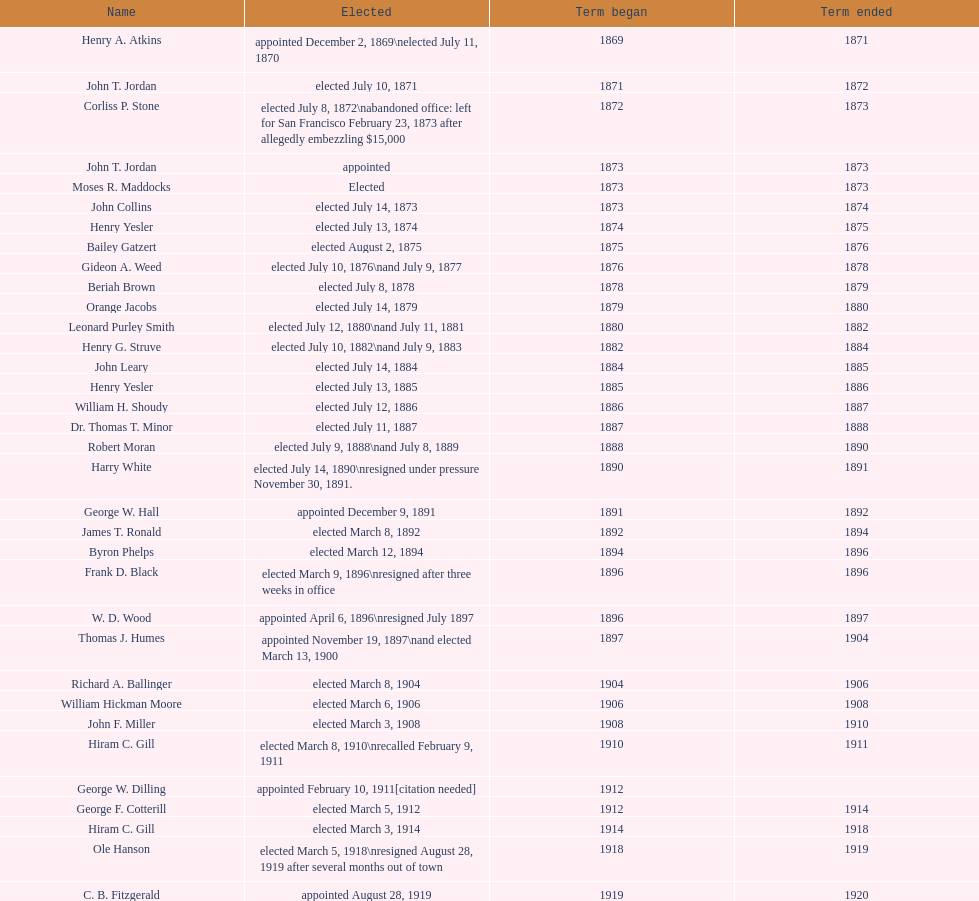How many days did robert moran serve? 365. 